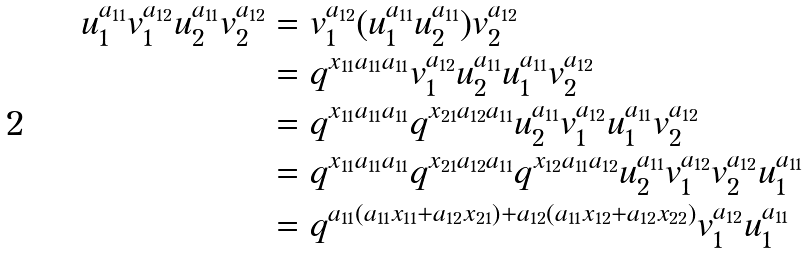<formula> <loc_0><loc_0><loc_500><loc_500>u _ { 1 } ^ { a _ { 1 1 } } v _ { 1 } ^ { a _ { 1 2 } } u _ { 2 } ^ { a _ { 1 1 } } v _ { 2 } ^ { a _ { 1 2 } } & = v _ { 1 } ^ { a _ { 1 2 } } ( u _ { 1 } ^ { a _ { 1 1 } } u _ { 2 } ^ { a _ { 1 1 } } ) v _ { 2 } ^ { a _ { 1 2 } } \\ & = q ^ { x _ { 1 1 } a _ { 1 1 } a _ { 1 1 } } v _ { 1 } ^ { a _ { 1 2 } } u _ { 2 } ^ { a _ { 1 1 } } u _ { 1 } ^ { a _ { 1 1 } } v _ { 2 } ^ { a _ { 1 2 } } \\ & = q ^ { x _ { 1 1 } a _ { 1 1 } a _ { 1 1 } } q ^ { x _ { 2 1 } a _ { 1 2 } a _ { 1 1 } } u _ { 2 } ^ { a _ { 1 1 } } v _ { 1 } ^ { a _ { 1 2 } } u _ { 1 } ^ { a _ { 1 1 } } v _ { 2 } ^ { a _ { 1 2 } } \\ & = q ^ { x _ { 1 1 } a _ { 1 1 } a _ { 1 1 } } q ^ { x _ { 2 1 } a _ { 1 2 } a _ { 1 1 } } q ^ { x _ { 1 2 } a _ { 1 1 } a _ { 1 2 } } u _ { 2 } ^ { a _ { 1 1 } } v _ { 1 } ^ { a _ { 1 2 } } v _ { 2 } ^ { a _ { 1 2 } } u _ { 1 } ^ { a _ { 1 1 } } \\ & = q ^ { a _ { 1 1 } ( a _ { 1 1 } x _ { 1 1 } + a _ { 1 2 } x _ { 2 1 } ) + a _ { 1 2 } ( a _ { 1 1 } x _ { 1 2 } + a _ { 1 2 } x _ { 2 2 } ) } v _ { 1 } ^ { a _ { 1 2 } } u _ { 1 } ^ { a _ { 1 1 } } \\</formula> 